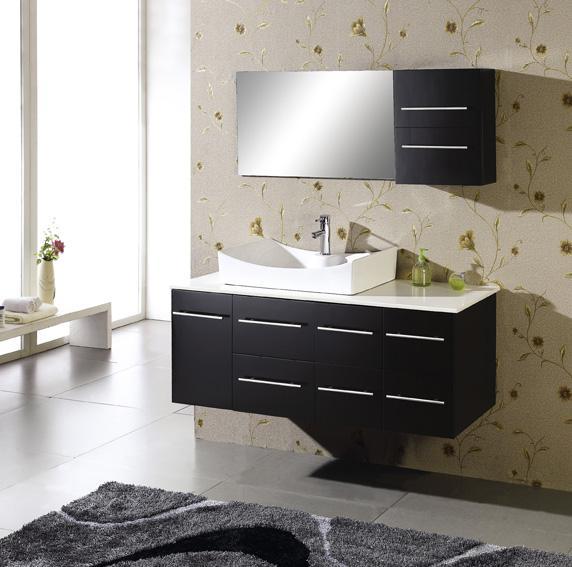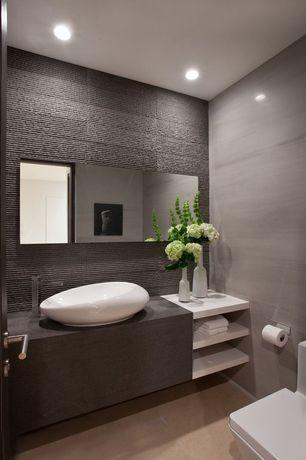The first image is the image on the left, the second image is the image on the right. Assess this claim about the two images: "At least one of the sinks has a floral arrangement next to it.". Correct or not? Answer yes or no. Yes. 